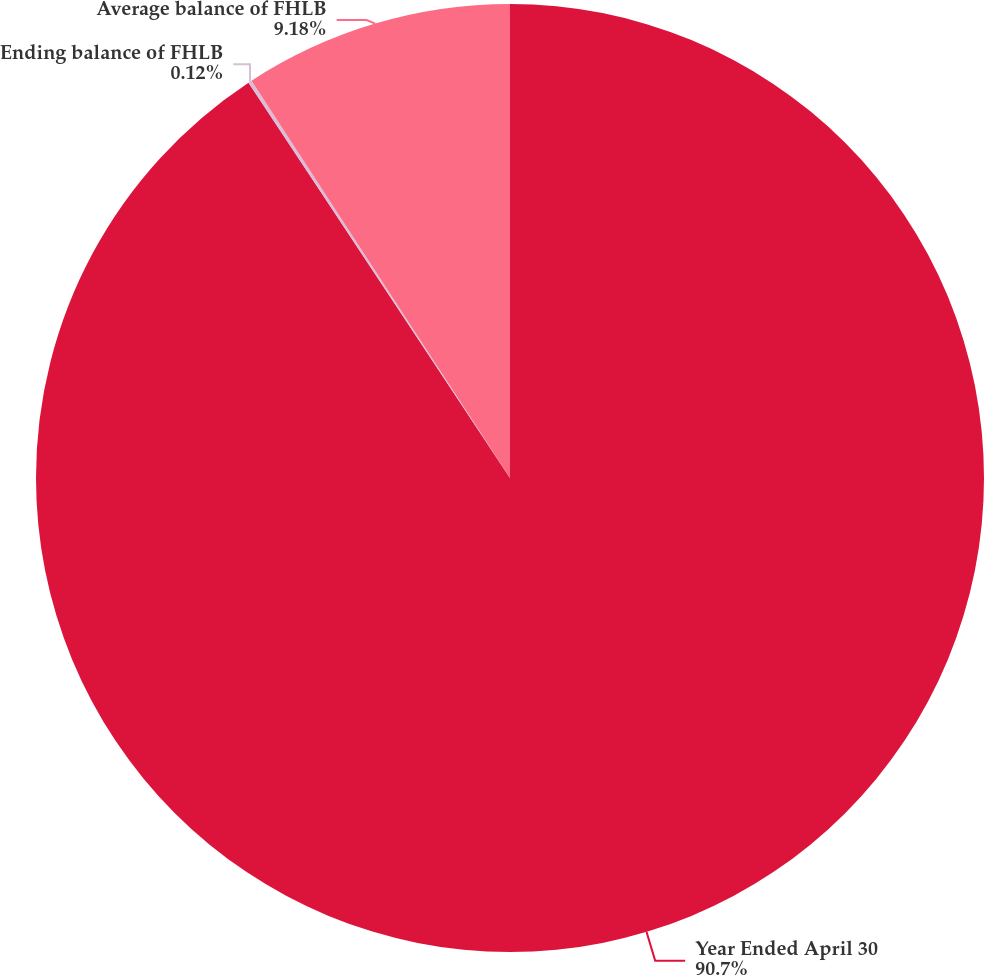Convert chart. <chart><loc_0><loc_0><loc_500><loc_500><pie_chart><fcel>Year Ended April 30<fcel>Ending balance of FHLB<fcel>Average balance of FHLB<nl><fcel>90.7%<fcel>0.12%<fcel>9.18%<nl></chart> 